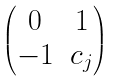<formula> <loc_0><loc_0><loc_500><loc_500>\begin{pmatrix} 0 & 1 \\ - 1 & c _ { j } \end{pmatrix}</formula> 